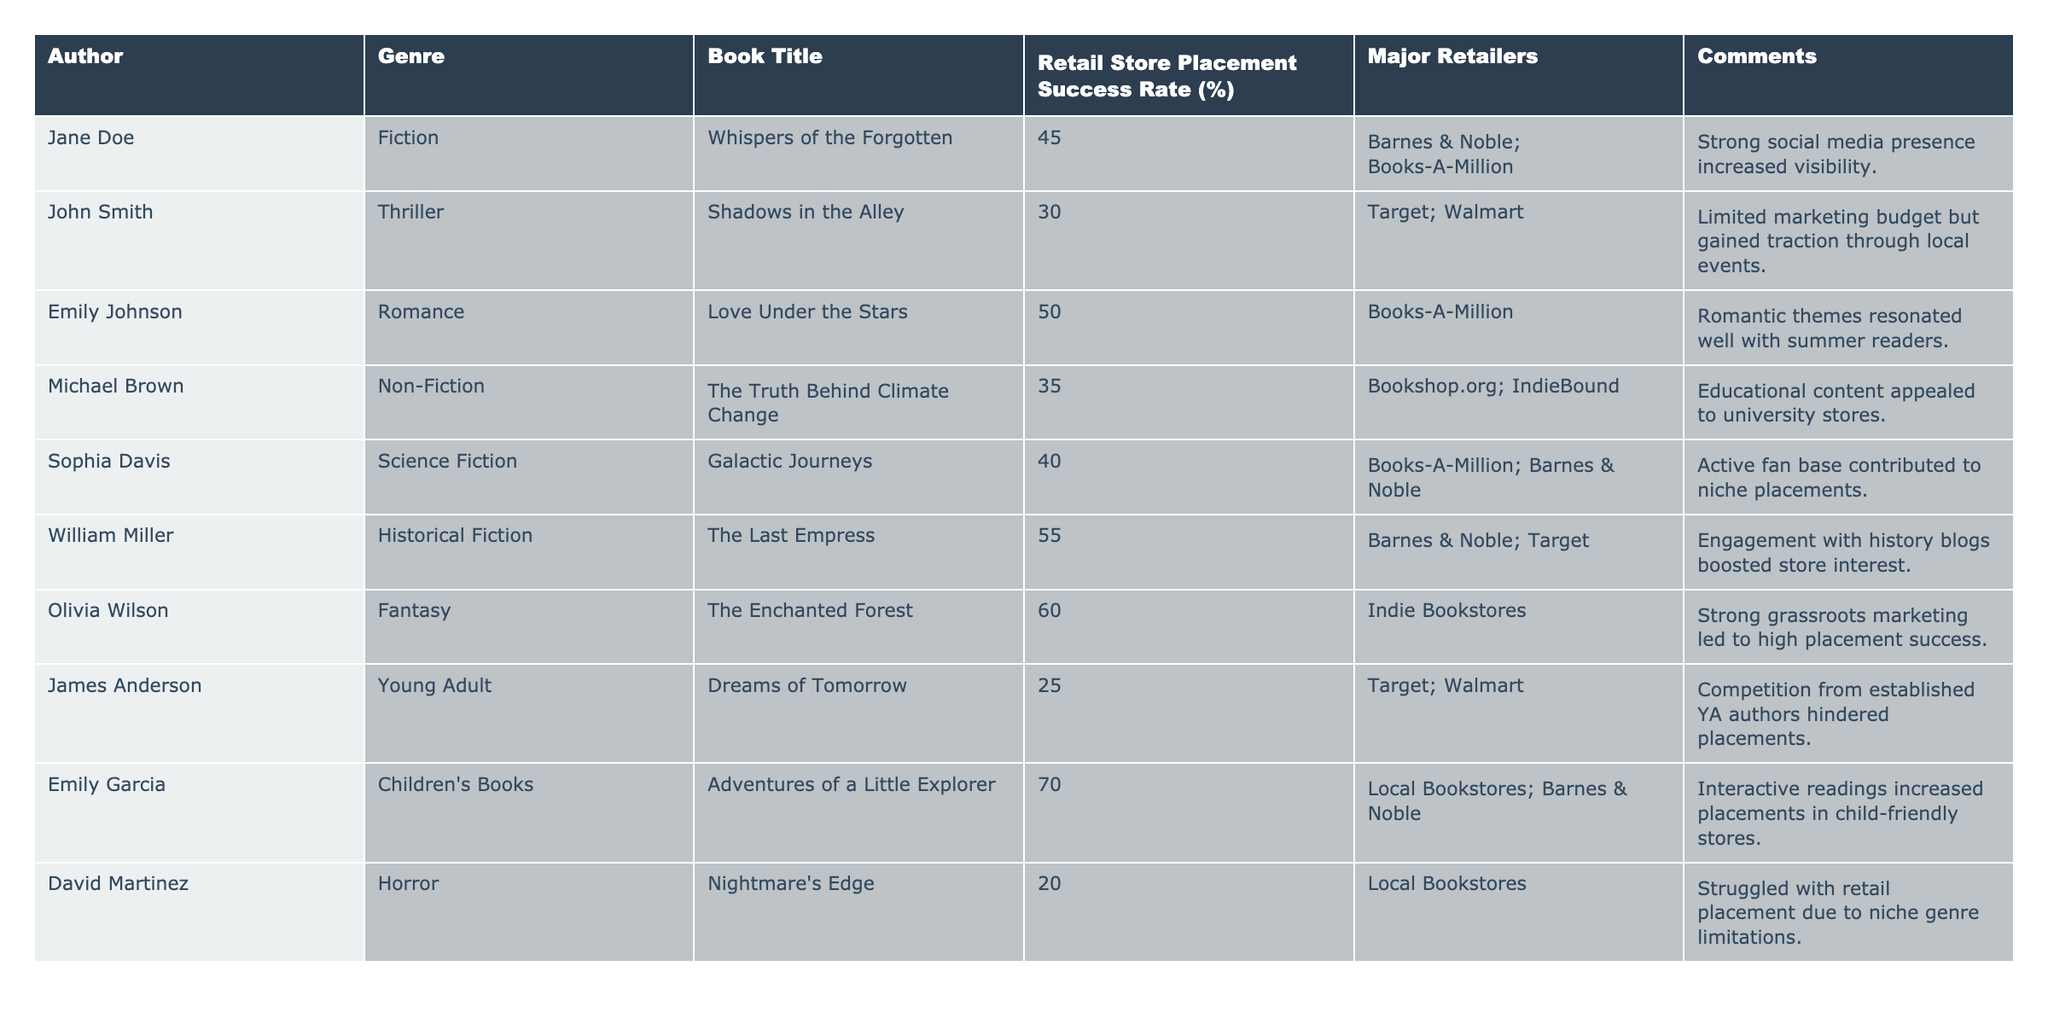What is the highest retail store placement success rate among the authors? The table shows that the highest success rate is for "Emily Garcia" with a rate of 70%.
Answer: 70% Which author had the lowest placement success rate? "David Martinez" had the lowest success rate at 20%.
Answer: 20% How many authors achieved a placement success rate of 50% or higher? The table lists 5 authors with a success rate of 50% or higher: Emily Johnson, William Miller, Olivia Wilson, and Emily Garcia.
Answer: 4 What is the average placement success rate of the authors listed? The success rates of the authors are (45 + 30 + 50 + 35 + 40 + 55 + 60 + 25 + 70 + 20) =  430. There are 10 authors, so the average rate is 430 / 10 = 43%.
Answer: 43% Did any authors achieve success through local bookstores? Yes, both "Emily Garcia" and "David Martinez" had placements in local bookstores.
Answer: Yes What genre had the highest retail placement success rate and what was the rate? The genre with the highest success rate is Children's Books, represented by "Emily Garcia" with a rate of 70%.
Answer: Children's Books, 70% What was the placement success rate for the Fiction genre? "Jane Doe" achieved a placement success rate of 45% in the Fiction genre.
Answer: 45% How does the placement success rate of Young Adult compare to Romance? "James Anderson" in Young Adult has a success rate of 25%, while "Emily Johnson" in Romance has a rate of 50%, making Romance significantly higher.
Answer: Romance is higher What percentage of the major retailers listed for the author "Michael Brown" align with the authors who had a success rate below 40%? "Michael Brown" is listed at 35%, and the only other author under 40% is "David Martinez" at 20%; both have different retailers.
Answer: 0% alignment Which author had strong grassroots marketing contributing to their placement success? "Olivia Wilson" benefited from a strong grassroots marketing approach leading to a 60% success rate.
Answer: Olivia Wilson 